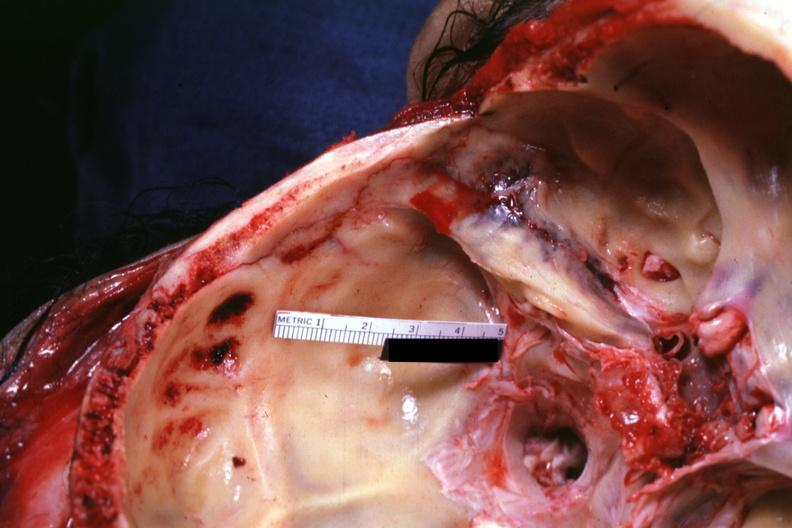what does this image show?
Answer the question using a single word or phrase. Close-up of linear fracture very well 